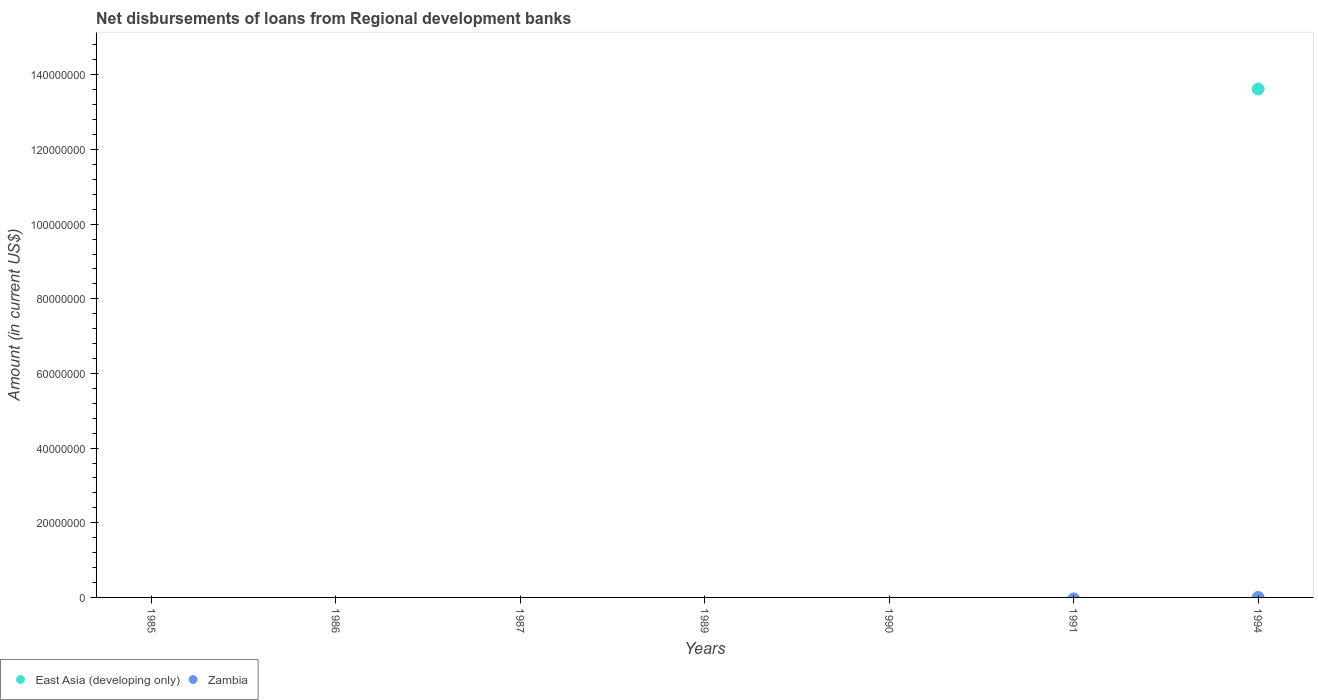How many different coloured dotlines are there?
Provide a short and direct response. 1. Is the number of dotlines equal to the number of legend labels?
Provide a short and direct response. No. What is the amount of disbursements of loans from regional development banks in Zambia in 1989?
Offer a terse response. 0. Across all years, what is the maximum amount of disbursements of loans from regional development banks in East Asia (developing only)?
Make the answer very short. 1.36e+08. Across all years, what is the minimum amount of disbursements of loans from regional development banks in East Asia (developing only)?
Give a very brief answer. 0. In which year was the amount of disbursements of loans from regional development banks in East Asia (developing only) maximum?
Your answer should be compact. 1994. What is the total amount of disbursements of loans from regional development banks in Zambia in the graph?
Your answer should be very brief. 0. What is the difference between the amount of disbursements of loans from regional development banks in East Asia (developing only) in 1991 and the amount of disbursements of loans from regional development banks in Zambia in 1990?
Provide a succinct answer. 0. What is the difference between the highest and the lowest amount of disbursements of loans from regional development banks in East Asia (developing only)?
Your answer should be very brief. 1.36e+08. Does the amount of disbursements of loans from regional development banks in East Asia (developing only) monotonically increase over the years?
Keep it short and to the point. No. Does the graph contain any zero values?
Keep it short and to the point. Yes. Where does the legend appear in the graph?
Offer a terse response. Bottom left. How are the legend labels stacked?
Offer a terse response. Horizontal. What is the title of the graph?
Keep it short and to the point. Net disbursements of loans from Regional development banks. What is the label or title of the X-axis?
Keep it short and to the point. Years. What is the Amount (in current US$) of East Asia (developing only) in 1985?
Provide a succinct answer. 0. What is the Amount (in current US$) of Zambia in 1986?
Make the answer very short. 0. What is the Amount (in current US$) of East Asia (developing only) in 1989?
Offer a terse response. 0. What is the Amount (in current US$) of East Asia (developing only) in 1994?
Keep it short and to the point. 1.36e+08. Across all years, what is the maximum Amount (in current US$) in East Asia (developing only)?
Make the answer very short. 1.36e+08. Across all years, what is the minimum Amount (in current US$) in East Asia (developing only)?
Your answer should be very brief. 0. What is the total Amount (in current US$) of East Asia (developing only) in the graph?
Provide a succinct answer. 1.36e+08. What is the average Amount (in current US$) of East Asia (developing only) per year?
Ensure brevity in your answer.  1.95e+07. What is the average Amount (in current US$) of Zambia per year?
Your answer should be compact. 0. What is the difference between the highest and the lowest Amount (in current US$) in East Asia (developing only)?
Provide a short and direct response. 1.36e+08. 